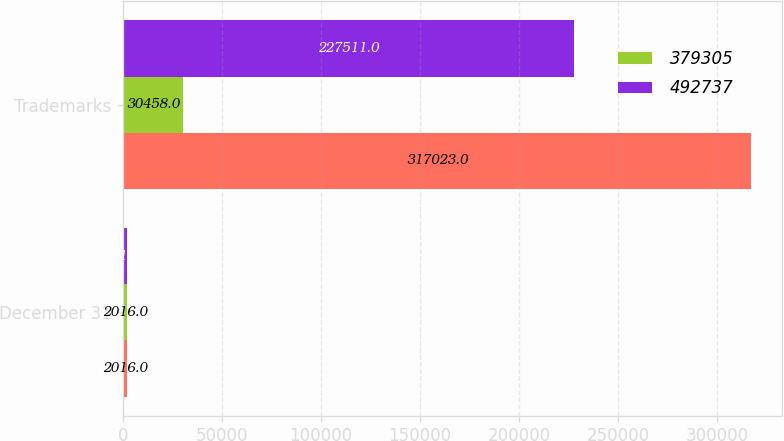Convert chart. <chart><loc_0><loc_0><loc_500><loc_500><stacked_bar_chart><ecel><fcel>December 31<fcel>Trademarks<nl><fcel>nan<fcel>2016<fcel>317023<nl><fcel>379305<fcel>2016<fcel>30458<nl><fcel>492737<fcel>2015<fcel>227511<nl></chart> 